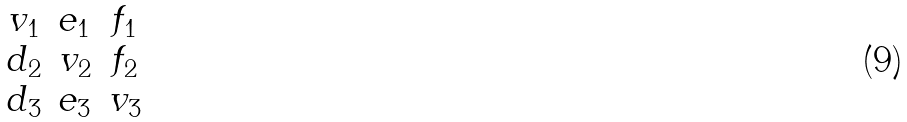Convert formula to latex. <formula><loc_0><loc_0><loc_500><loc_500>\begin{matrix} v _ { 1 } & e _ { 1 } & f _ { 1 } \\ d _ { 2 } & v _ { 2 } & f _ { 2 } \\ d _ { 3 } & e _ { 3 } & v _ { 3 } \end{matrix}</formula> 